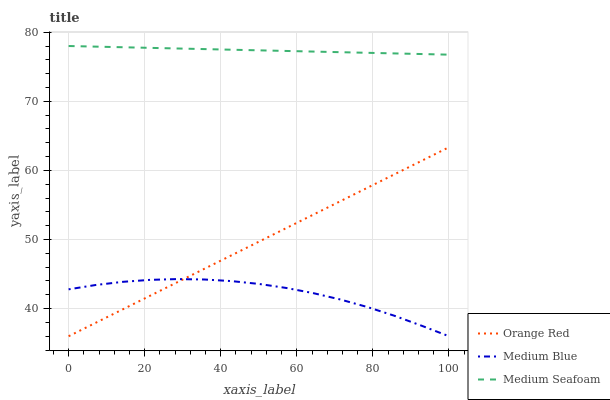Does Orange Red have the minimum area under the curve?
Answer yes or no. No. Does Orange Red have the maximum area under the curve?
Answer yes or no. No. Is Medium Seafoam the smoothest?
Answer yes or no. No. Is Medium Seafoam the roughest?
Answer yes or no. No. Does Medium Seafoam have the lowest value?
Answer yes or no. No. Does Orange Red have the highest value?
Answer yes or no. No. Is Orange Red less than Medium Seafoam?
Answer yes or no. Yes. Is Medium Seafoam greater than Orange Red?
Answer yes or no. Yes. Does Orange Red intersect Medium Seafoam?
Answer yes or no. No. 